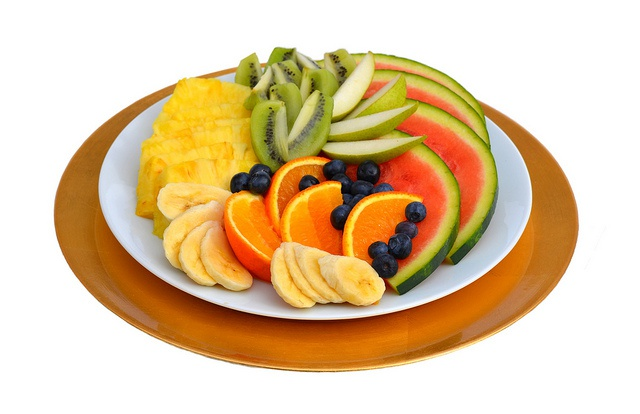Describe the objects in this image and their specific colors. I can see orange in white, gold, orange, and olive tones, banana in white, gold, orange, and khaki tones, apple in white, khaki, olive, and beige tones, banana in white, gold, khaki, tan, and orange tones, and orange in white, red, orange, and gold tones in this image. 